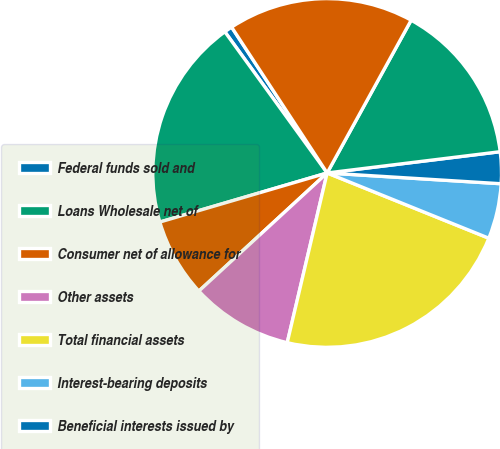<chart> <loc_0><loc_0><loc_500><loc_500><pie_chart><fcel>Federal funds sold and<fcel>Loans Wholesale net of<fcel>Consumer net of allowance for<fcel>Other assets<fcel>Total financial assets<fcel>Interest-bearing deposits<fcel>Beneficial interests issued by<fcel>Long-term debt-related<fcel>Total financial liabilities<nl><fcel>0.75%<fcel>19.56%<fcel>7.3%<fcel>9.48%<fcel>22.57%<fcel>5.12%<fcel>2.93%<fcel>15.05%<fcel>17.23%<nl></chart> 